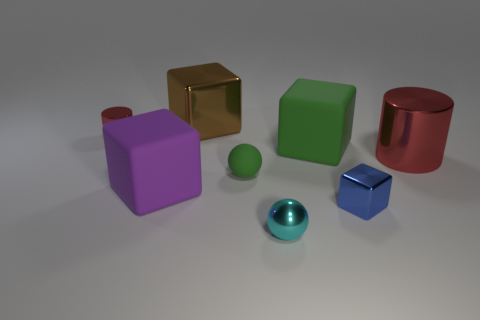Add 2 yellow spheres. How many objects exist? 10 Subtract all cylinders. How many objects are left? 6 Subtract all small red cylinders. Subtract all large purple cubes. How many objects are left? 6 Add 1 tiny green balls. How many tiny green balls are left? 2 Add 3 big red shiny cylinders. How many big red shiny cylinders exist? 4 Subtract 0 gray blocks. How many objects are left? 8 